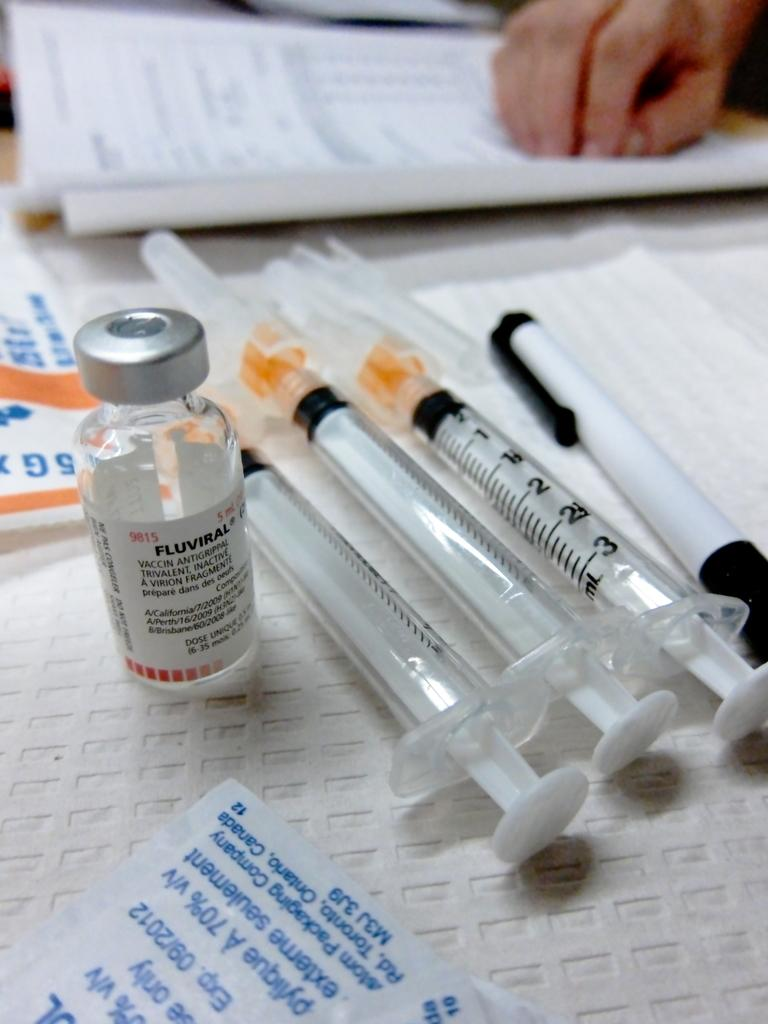What type of medical equipment can be seen in the image? There are syringes in the image. What writing instrument is present in the image? There is a pen in the image. What type of container is visible in the image? There is a bottle in the image. What type of stationery item is present in the image? There is an envelope in the image. What type of document or material is present in the image? There are papers in the image. Whose hand is visible in the image? A human hand is visible in the image. What is the color of the surface in the image? The surface in the image is white. What type of notebook is visible on the curtain in the image? There is no notebook or curtain present in the image. What type of store is depicted in the image? The image does not depict a store; it contains a collection of objects and a human hand. 